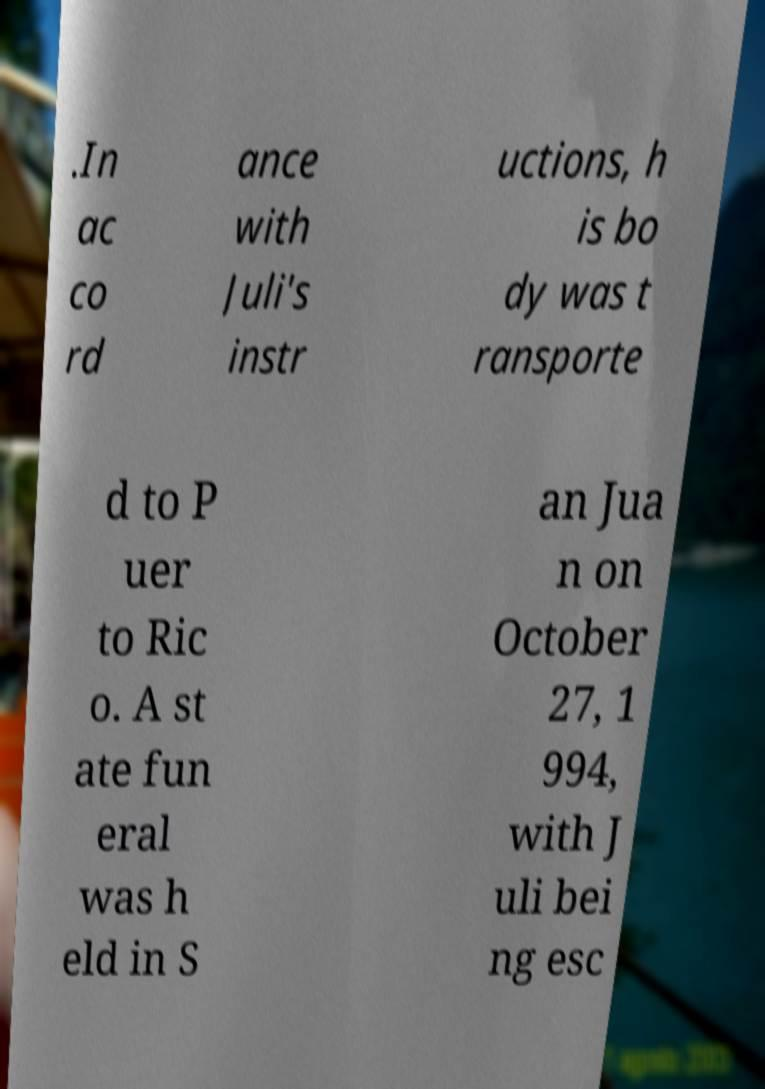Can you read and provide the text displayed in the image?This photo seems to have some interesting text. Can you extract and type it out for me? .In ac co rd ance with Juli's instr uctions, h is bo dy was t ransporte d to P uer to Ric o. A st ate fun eral was h eld in S an Jua n on October 27, 1 994, with J uli bei ng esc 